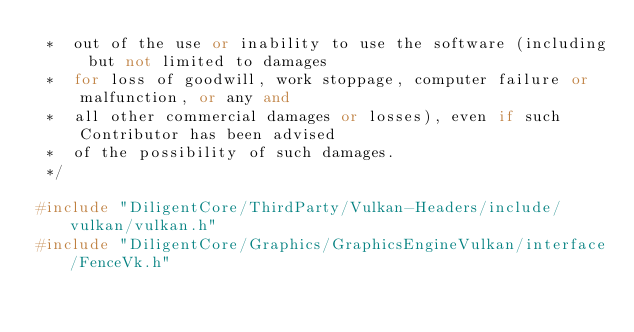<code> <loc_0><loc_0><loc_500><loc_500><_C++_> *  out of the use or inability to use the software (including but not limited to damages 
 *  for loss of goodwill, work stoppage, computer failure or malfunction, or any and 
 *  all other commercial damages or losses), even if such Contributor has been advised 
 *  of the possibility of such damages.
 */

#include "DiligentCore/ThirdParty/Vulkan-Headers/include/vulkan/vulkan.h"
#include "DiligentCore/Graphics/GraphicsEngineVulkan/interface/FenceVk.h"
</code> 